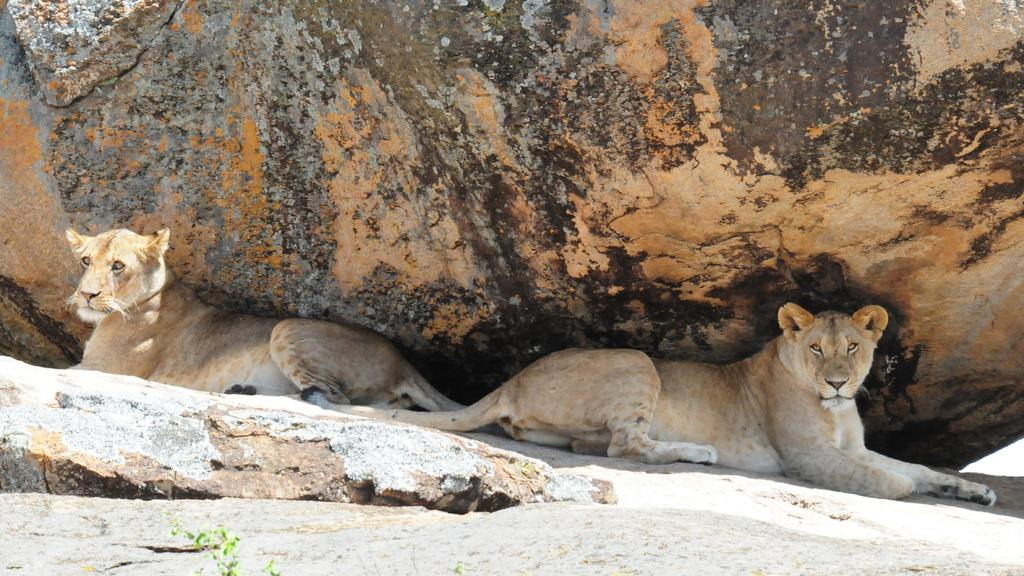What animals are present in the image? There are two lionesses in the image. What are the lionesses doing in the image? The lionesses are lying on the ground. What can be seen above the lionesses in the image? There is a rock above the lionesses in the image. Can you see a hole in the ground near the lionesses in the image? There is no mention of a hole in the ground in the provided facts, so we cannot determine if one is present in the image. 